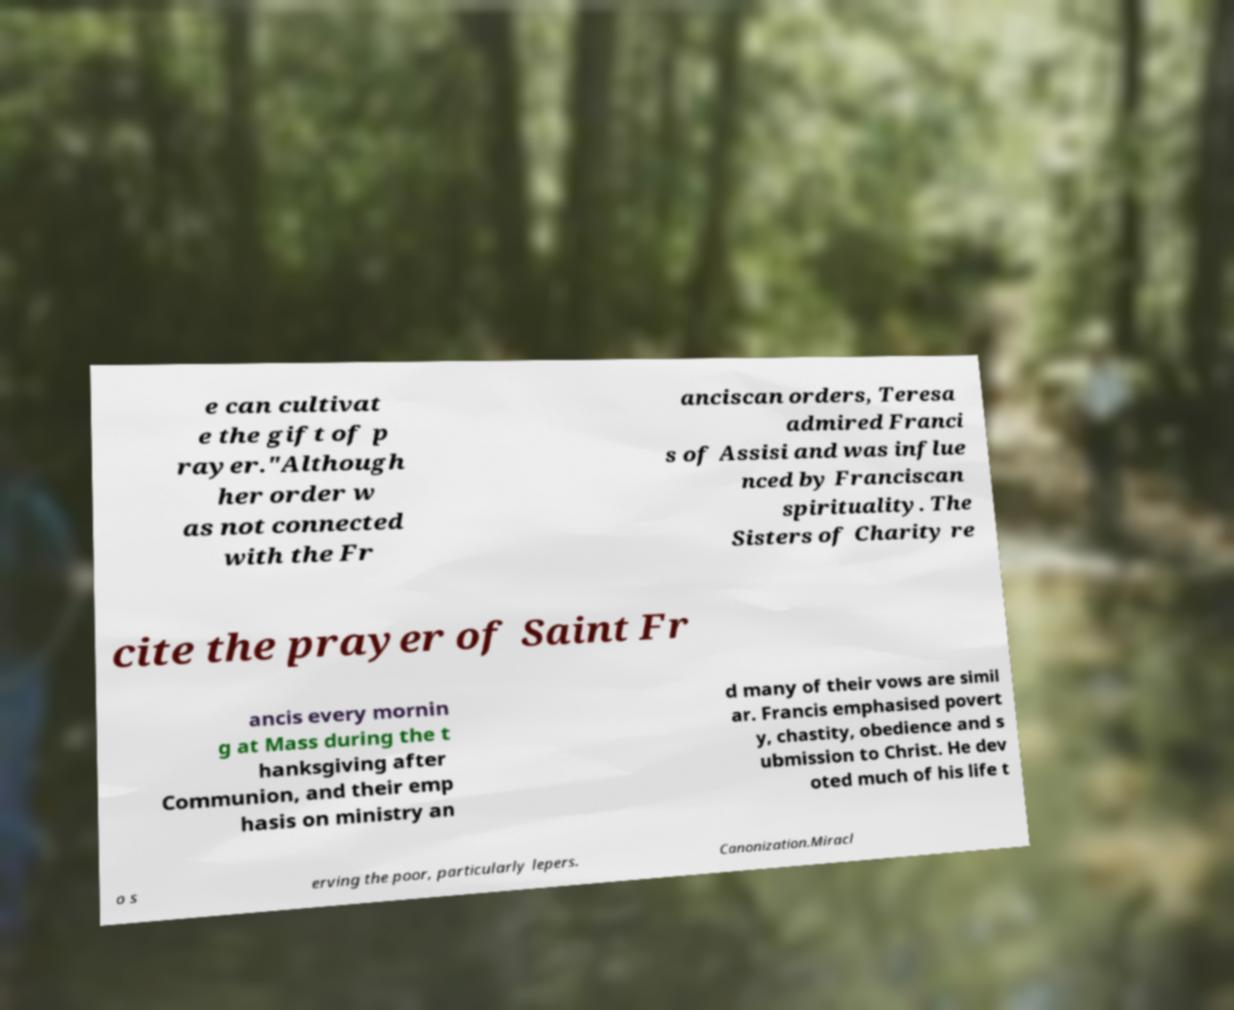Could you extract and type out the text from this image? e can cultivat e the gift of p rayer."Although her order w as not connected with the Fr anciscan orders, Teresa admired Franci s of Assisi and was influe nced by Franciscan spirituality. The Sisters of Charity re cite the prayer of Saint Fr ancis every mornin g at Mass during the t hanksgiving after Communion, and their emp hasis on ministry an d many of their vows are simil ar. Francis emphasised povert y, chastity, obedience and s ubmission to Christ. He dev oted much of his life t o s erving the poor, particularly lepers. Canonization.Miracl 